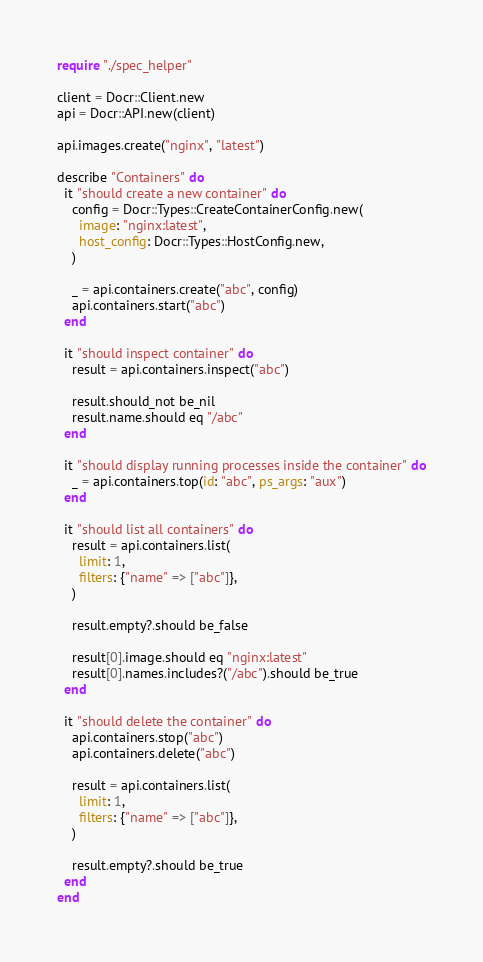<code> <loc_0><loc_0><loc_500><loc_500><_Crystal_>require "./spec_helper"

client = Docr::Client.new
api = Docr::API.new(client)

api.images.create("nginx", "latest")

describe "Containers" do
  it "should create a new container" do
    config = Docr::Types::CreateContainerConfig.new(
      image: "nginx:latest",
      host_config: Docr::Types::HostConfig.new,
    )

    _ = api.containers.create("abc", config)
    api.containers.start("abc")
  end

  it "should inspect container" do
    result = api.containers.inspect("abc")

    result.should_not be_nil
    result.name.should eq "/abc"
  end

  it "should display running processes inside the container" do
    _ = api.containers.top(id: "abc", ps_args: "aux")
  end

  it "should list all containers" do
    result = api.containers.list(
      limit: 1,
      filters: {"name" => ["abc"]},
    )

    result.empty?.should be_false

    result[0].image.should eq "nginx:latest"
    result[0].names.includes?("/abc").should be_true
  end

  it "should delete the container" do
    api.containers.stop("abc")
    api.containers.delete("abc")

    result = api.containers.list(
      limit: 1,
      filters: {"name" => ["abc"]},
    )

    result.empty?.should be_true
  end
end
</code> 